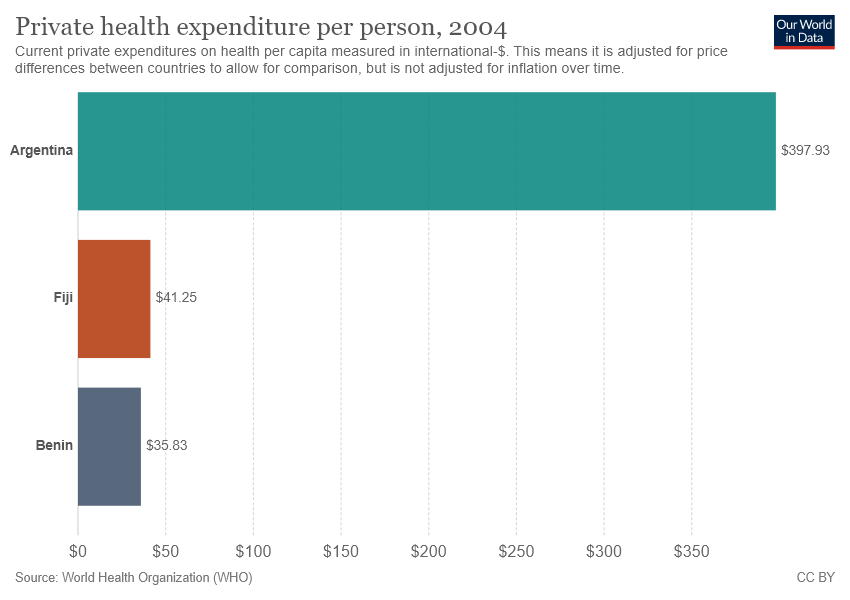Highlight a few significant elements in this photo. The sum value of Benin and Fiji is 77.08. The value of Orange bar is 41.25. 